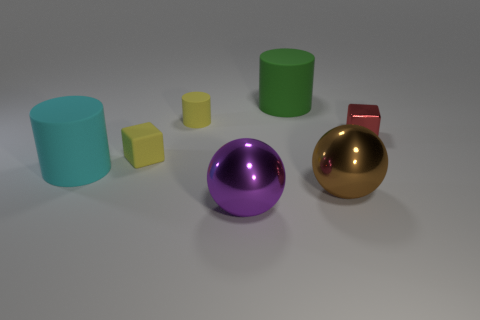Subtract all yellow cylinders. Subtract all purple blocks. How many cylinders are left? 2 Add 2 tiny red things. How many objects exist? 9 Subtract all spheres. How many objects are left? 5 Add 6 yellow matte cylinders. How many yellow matte cylinders are left? 7 Add 3 big green cylinders. How many big green cylinders exist? 4 Subtract 0 green cubes. How many objects are left? 7 Subtract all purple shiny objects. Subtract all large cyan metal objects. How many objects are left? 6 